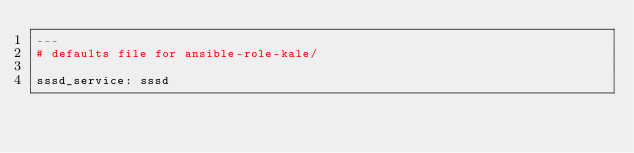<code> <loc_0><loc_0><loc_500><loc_500><_YAML_>---
# defaults file for ansible-role-kale/

sssd_service: sssd

</code> 